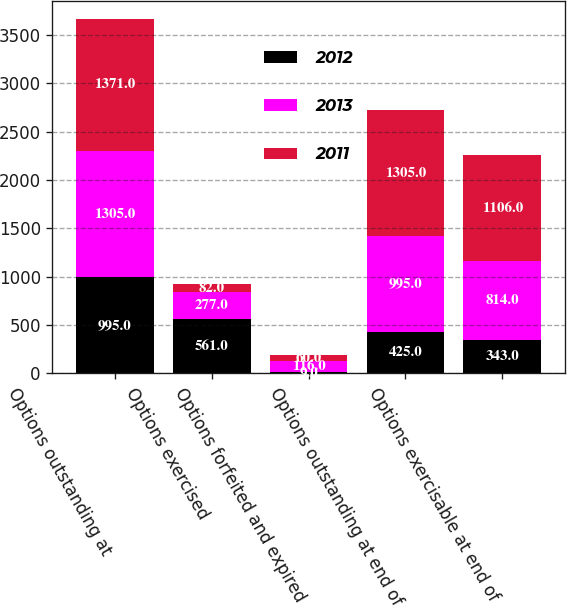Convert chart. <chart><loc_0><loc_0><loc_500><loc_500><stacked_bar_chart><ecel><fcel>Options outstanding at<fcel>Options exercised<fcel>Options forfeited and expired<fcel>Options outstanding at end of<fcel>Options exercisable at end of<nl><fcel>2012<fcel>995<fcel>561<fcel>9<fcel>425<fcel>343<nl><fcel>2013<fcel>1305<fcel>277<fcel>116<fcel>995<fcel>814<nl><fcel>2011<fcel>1371<fcel>82<fcel>60<fcel>1305<fcel>1106<nl></chart> 